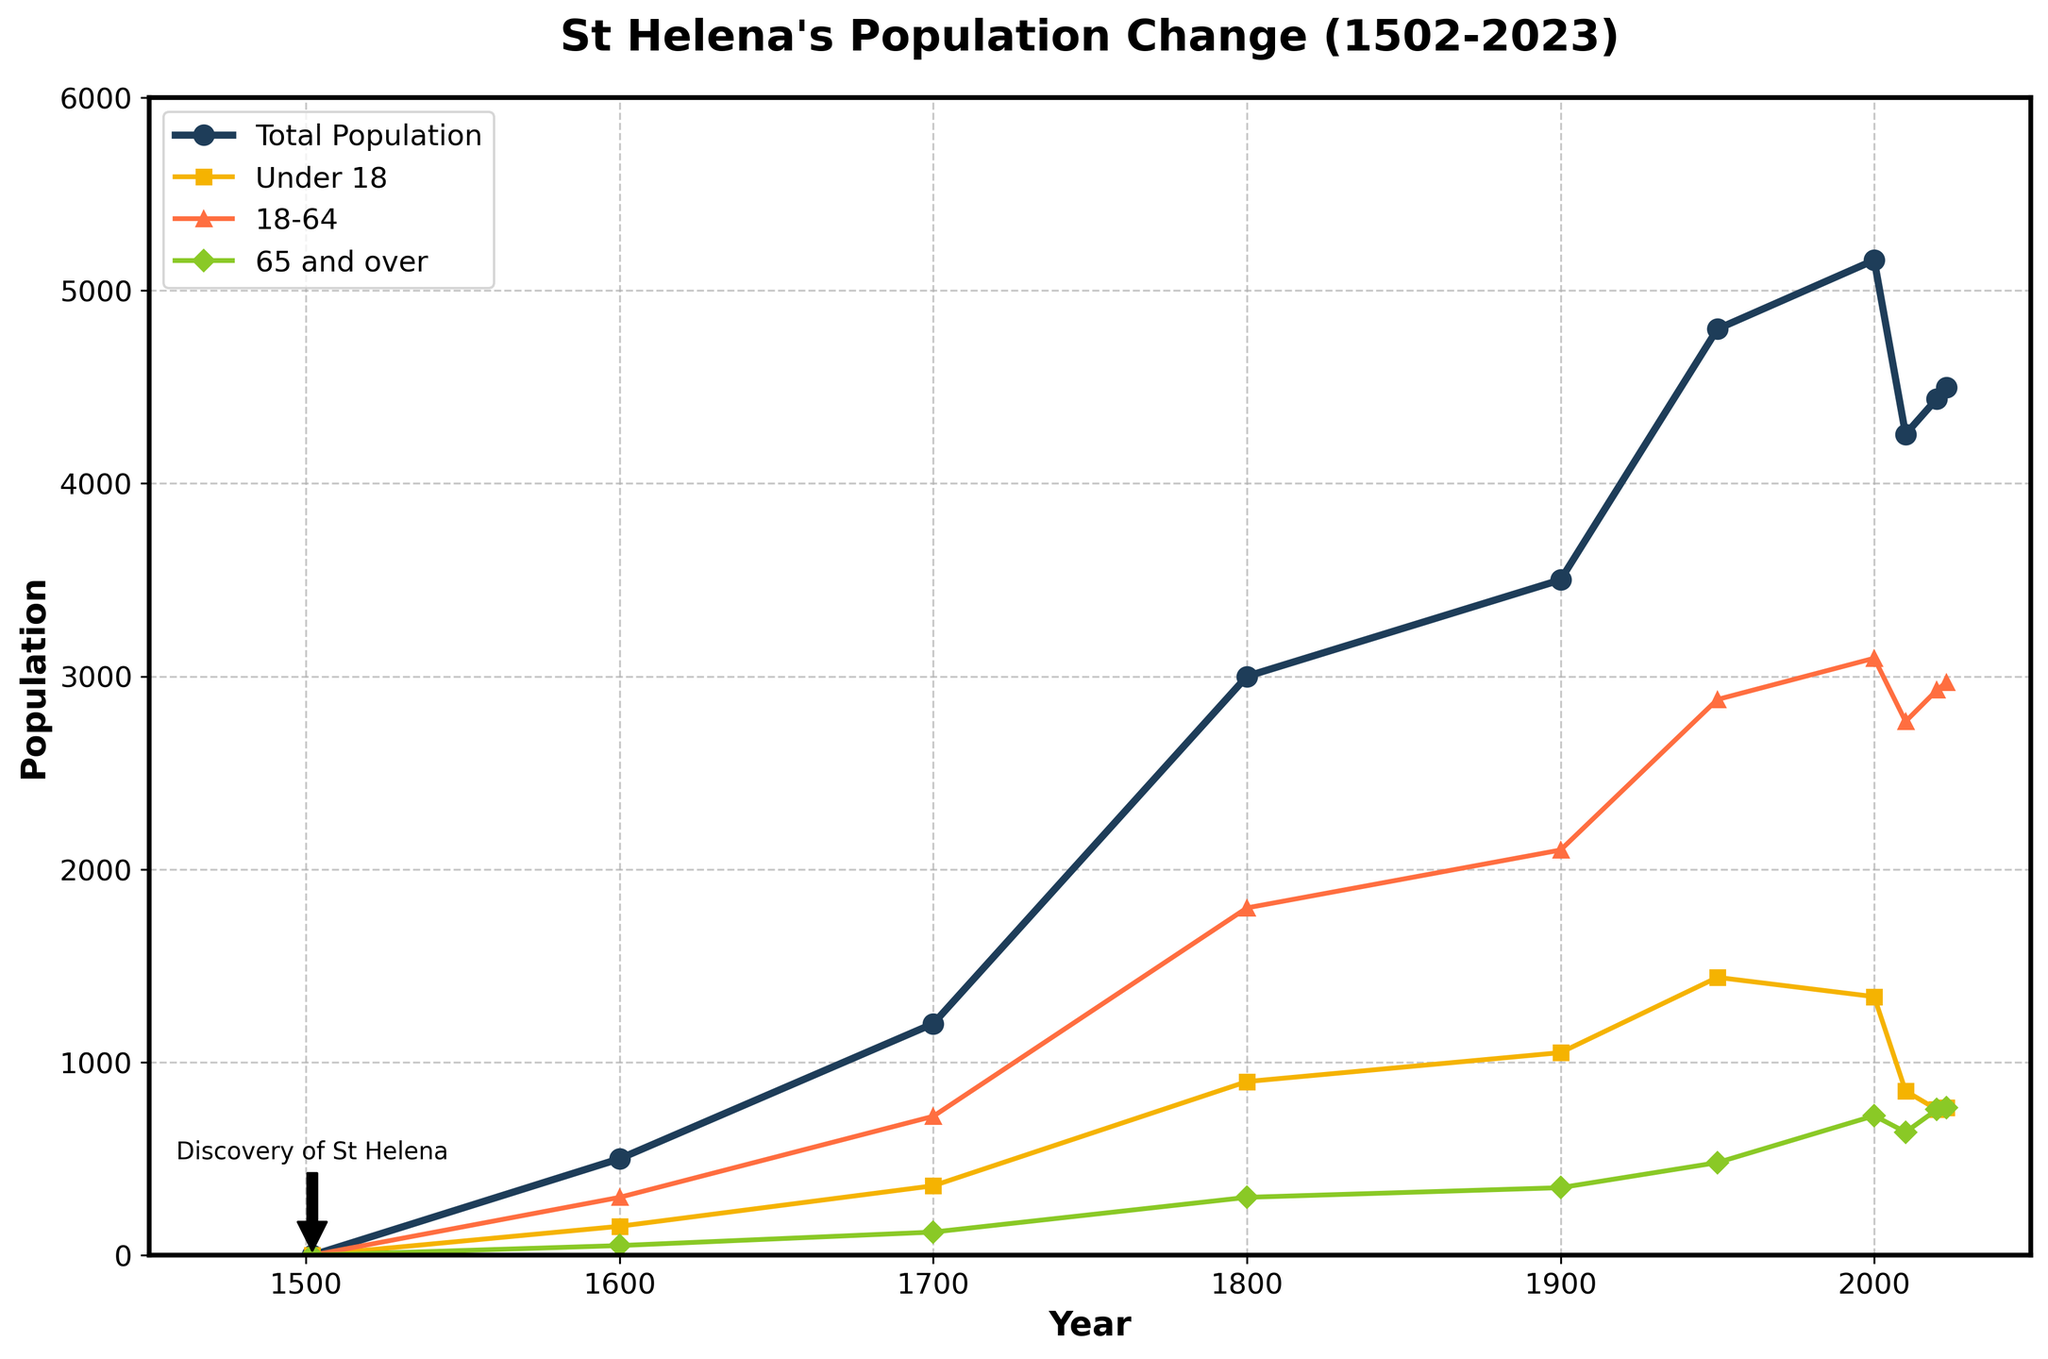Which year had the highest total population? By examining the line representing the total population, we see that the peak occurs around 2000.
Answer: 2000 Compare the population of Under 18 and 65 and over in 2023. Which group has a larger population? By identifying the two values in 2023, we see that Under 18 has a population of 764 and 65 and over has a population of 765.
Answer: 65 and over What is the difference in the population of the 18-64 age group between 2000 and 2010? The population of the 18-64 age group in 2000 is 3094 and in 2010 is 2766. The difference is found by subtracting 2766 from 3094.
Answer: 328 Which age group showed the greatest increase between 2010 and 2020? By examining the changes in populations, the Under 18 group decreases from 851 to 755, the 18-64 group increases from 2766 to 2929, and the 65 and over group increases from 638 to 755. The greatest increase is in the 65 and over group.
Answer: 65 and over How many years did it take for the total population to increase from 3000 to 3500? The population of 3000 occurred in 1800 and reached 3500 by 1900. The number of years between 1800 and 1900 is 100 years.
Answer: 100 What is the trend of the population of the 65 and over group from 1950 to 2023? Observing the line for the 65 and over group from 1950 to 2023, it shows a continuous increase.
Answer: Increasing Calculate the average population of the Under 18 age group from 1600 to 1800. The populations in 1600, 1700, and 1800 are 150, 360, and 900. Adding them up gives 1410. Dividing by the three data points, the average is 1410/3.
Answer: 470 Did the population of any age group decrease from 2000 to 2023? Comparing the population of each age group in 2000 and 2023, the Under 18 group goes from 1340 to 764, which shows a decrease.
Answer: Under 18 Which year had the highest population of the 18-64 age group? By looking at the peak of the 18-64 line, we see the highest population at 2000 with 3094.
Answer: 2000 